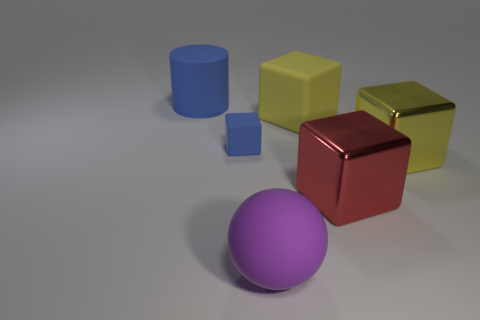Subtract all brown blocks. Subtract all cyan cylinders. How many blocks are left? 4 Add 2 large cylinders. How many objects exist? 8 Subtract all blocks. How many objects are left? 2 Subtract 0 green spheres. How many objects are left? 6 Subtract all big cyan spheres. Subtract all big purple matte balls. How many objects are left? 5 Add 6 spheres. How many spheres are left? 7 Add 4 small green metallic balls. How many small green metallic balls exist? 4 